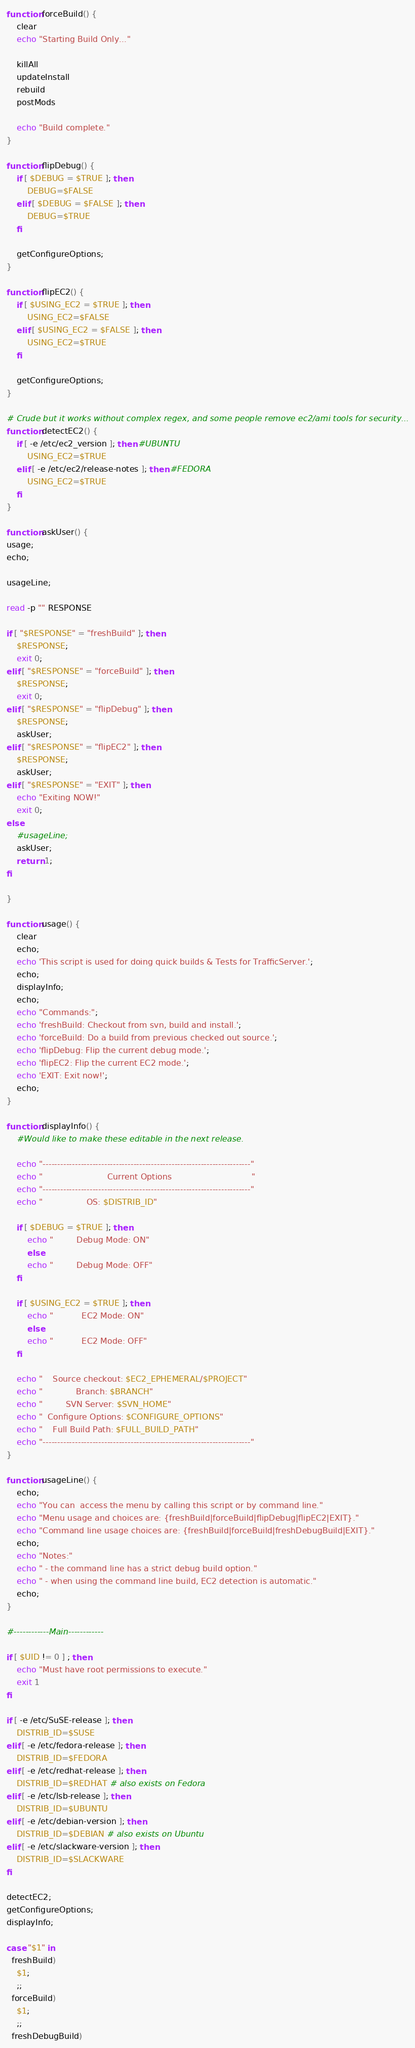<code> <loc_0><loc_0><loc_500><loc_500><_Bash_>
function forceBuild() {
    clear
    echo "Starting Build Only..."

    killAll
    updateInstall
    rebuild
    postMods

    echo "Build complete."
}

function flipDebug() {
    if [ $DEBUG = $TRUE ]; then
        DEBUG=$FALSE
    elif [ $DEBUG = $FALSE ]; then
        DEBUG=$TRUE
    fi

    getConfigureOptions;
}

function flipEC2() {
    if [ $USING_EC2 = $TRUE ]; then
        USING_EC2=$FALSE
    elif [ $USING_EC2 = $FALSE ]; then
        USING_EC2=$TRUE
    fi

    getConfigureOptions;
}

# Crude but it works without complex regex, and some people remove ec2/ami tools for security...
function detectEC2() {
    if [ -e /etc/ec2_version ]; then #UBUNTU
        USING_EC2=$TRUE
    elif [ -e /etc/ec2/release-notes ]; then #FEDORA
        USING_EC2=$TRUE
    fi
}

function askUser() {
usage;
echo;

usageLine;

read -p "" RESPONSE

if [ "$RESPONSE" = "freshBuild" ]; then
    $RESPONSE;
    exit 0;
elif [ "$RESPONSE" = "forceBuild" ]; then
    $RESPONSE;
    exit 0;
elif [ "$RESPONSE" = "flipDebug" ]; then
    $RESPONSE;
    askUser;
elif [ "$RESPONSE" = "flipEC2" ]; then
    $RESPONSE;
    askUser;
elif [ "$RESPONSE" = "EXIT" ]; then
    echo "Exiting NOW!"
    exit 0;
else
    #usageLine;
    askUser;
    return 1;
fi

}

function usage() {
    clear
    echo;
    echo 'This script is used for doing quick builds & Tests for TrafficServer.';
    echo;
    displayInfo;
    echo;
    echo "Commands:";
    echo 'freshBuild: Checkout from svn, build and install.';
    echo 'forceBuild: Do a build from previous checked out source.';
    echo 'flipDebug: Flip the current debug mode.';
    echo 'flipEC2: Flip the current EC2 mode.';
    echo 'EXIT: Exit now!';
    echo;
}

function displayInfo() {
    #Would like to make these editable in the next release.

    echo "-----------------------------------------------------------------------"
    echo "                         Current Options                               "
    echo "-----------------------------------------------------------------------"
    echo "                 OS: $DISTRIB_ID"

    if [ $DEBUG = $TRUE ]; then
        echo "         Debug Mode: ON"
        else
        echo "         Debug Mode: OFF"
    fi

    if [ $USING_EC2 = $TRUE ]; then
        echo "           EC2 Mode: ON"
        else
        echo "           EC2 Mode: OFF"
    fi

    echo "    Source checkout: $EC2_EPHEMERAL/$PROJECT"
    echo "             Branch: $BRANCH"
    echo "         SVN Server: $SVN_HOME"
    echo "  Configure Options: $CONFIGURE_OPTIONS"
    echo "    Full Build Path: $FULL_BUILD_PATH"
    echo "-----------------------------------------------------------------------"
}

function usageLine() {
    echo;
    echo "You can  access the menu by calling this script or by command line."
    echo "Menu usage and choices are: {freshBuild|forceBuild|flipDebug|flipEC2|EXIT}."
    echo "Command line usage choices are: {freshBuild|forceBuild|freshDebugBuild|EXIT}."
    echo;
    echo "Notes:"
    echo " - the command line has a strict debug build option."
    echo " - when using the command line build, EC2 detection is automatic."
    echo;
}

#------------Main------------

if [ $UID != 0 ] ; then
    echo "Must have root permissions to execute."
    exit 1
fi

if [ -e /etc/SuSE-release ]; then
    DISTRIB_ID=$SUSE
elif [ -e /etc/fedora-release ]; then
    DISTRIB_ID=$FEDORA
elif [ -e /etc/redhat-release ]; then
    DISTRIB_ID=$REDHAT # also exists on Fedora
elif [ -e /etc/lsb-release ]; then
    DISTRIB_ID=$UBUNTU
elif [ -e /etc/debian-version ]; then
    DISTRIB_ID=$DEBIAN # also exists on Ubuntu
elif [ -e /etc/slackware-version ]; then
    DISTRIB_ID=$SLACKWARE
fi

detectEC2;
getConfigureOptions;
displayInfo;

case "$1" in
  freshBuild)
    $1;
    ;;
  forceBuild)
    $1;
    ;;
  freshDebugBuild)</code> 